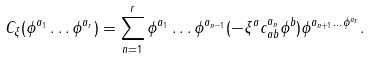Convert formula to latex. <formula><loc_0><loc_0><loc_500><loc_500>C _ { \xi } ( \phi ^ { a _ { 1 } } \dots \phi ^ { a _ { r } } ) = \sum _ { n = 1 } ^ { r } \phi ^ { a _ { 1 } } \dots \phi ^ { a _ { n - 1 } } ( - \xi ^ { a } c _ { a b } ^ { a _ { n } } \phi ^ { b } ) \phi ^ { a _ { n + 1 } \dots \phi ^ { a _ { r } } } .</formula> 